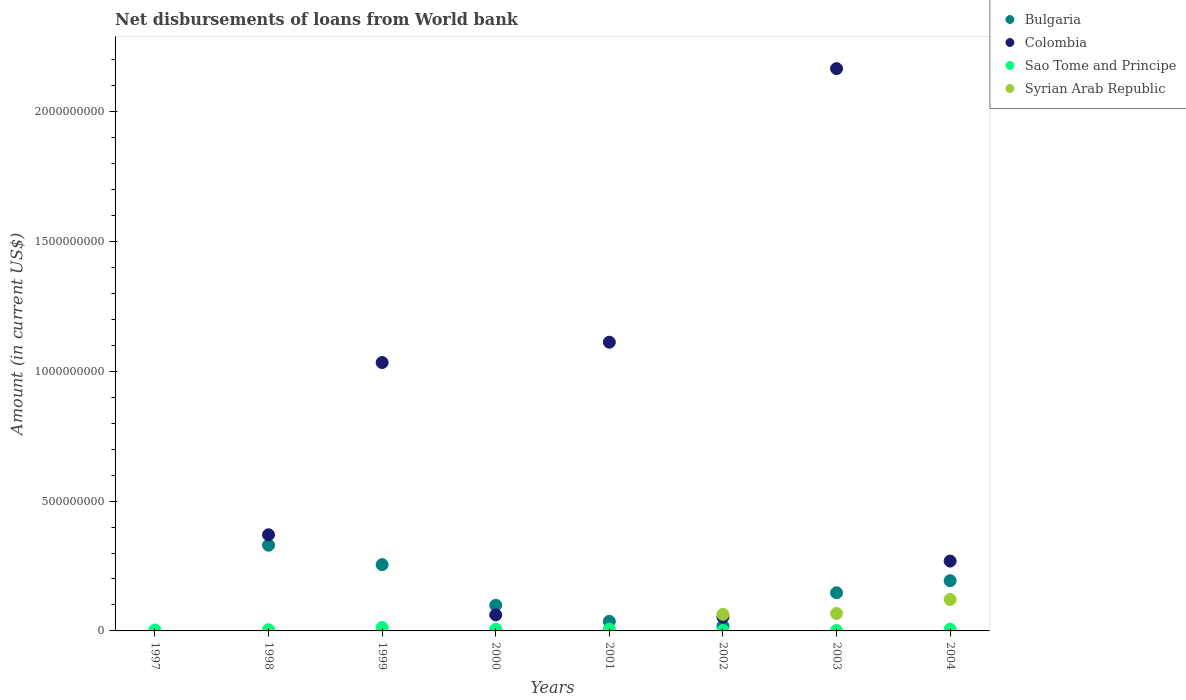Is the number of dotlines equal to the number of legend labels?
Offer a very short reply. No. What is the amount of loan disbursed from World Bank in Sao Tome and Principe in 2003?
Your response must be concise. 1.70e+06. Across all years, what is the maximum amount of loan disbursed from World Bank in Syrian Arab Republic?
Your answer should be very brief. 1.21e+08. Across all years, what is the minimum amount of loan disbursed from World Bank in Syrian Arab Republic?
Ensure brevity in your answer.  0. In which year was the amount of loan disbursed from World Bank in Bulgaria maximum?
Your response must be concise. 1998. What is the total amount of loan disbursed from World Bank in Syrian Arab Republic in the graph?
Ensure brevity in your answer.  2.52e+08. What is the difference between the amount of loan disbursed from World Bank in Sao Tome and Principe in 1998 and that in 2004?
Your answer should be compact. -2.05e+06. What is the difference between the amount of loan disbursed from World Bank in Syrian Arab Republic in 2000 and the amount of loan disbursed from World Bank in Colombia in 2001?
Offer a terse response. -1.11e+09. What is the average amount of loan disbursed from World Bank in Colombia per year?
Offer a terse response. 6.33e+08. In the year 2004, what is the difference between the amount of loan disbursed from World Bank in Sao Tome and Principe and amount of loan disbursed from World Bank in Syrian Arab Republic?
Provide a succinct answer. -1.14e+08. In how many years, is the amount of loan disbursed from World Bank in Colombia greater than 1600000000 US$?
Your response must be concise. 1. What is the ratio of the amount of loan disbursed from World Bank in Sao Tome and Principe in 1999 to that in 2002?
Keep it short and to the point. 8.31. What is the difference between the highest and the second highest amount of loan disbursed from World Bank in Bulgaria?
Offer a very short reply. 7.48e+07. What is the difference between the highest and the lowest amount of loan disbursed from World Bank in Bulgaria?
Provide a succinct answer. 3.30e+08. Is the sum of the amount of loan disbursed from World Bank in Colombia in 1998 and 2004 greater than the maximum amount of loan disbursed from World Bank in Sao Tome and Principe across all years?
Offer a terse response. Yes. Is it the case that in every year, the sum of the amount of loan disbursed from World Bank in Syrian Arab Republic and amount of loan disbursed from World Bank in Bulgaria  is greater than the sum of amount of loan disbursed from World Bank in Colombia and amount of loan disbursed from World Bank in Sao Tome and Principe?
Your response must be concise. No. Does the amount of loan disbursed from World Bank in Sao Tome and Principe monotonically increase over the years?
Make the answer very short. No. Is the amount of loan disbursed from World Bank in Syrian Arab Republic strictly less than the amount of loan disbursed from World Bank in Bulgaria over the years?
Provide a short and direct response. No. What is the difference between two consecutive major ticks on the Y-axis?
Your response must be concise. 5.00e+08. Are the values on the major ticks of Y-axis written in scientific E-notation?
Make the answer very short. No. Does the graph contain any zero values?
Keep it short and to the point. Yes. Does the graph contain grids?
Give a very brief answer. No. Where does the legend appear in the graph?
Provide a short and direct response. Top right. How are the legend labels stacked?
Ensure brevity in your answer.  Vertical. What is the title of the graph?
Your answer should be compact. Net disbursements of loans from World bank. Does "United States" appear as one of the legend labels in the graph?
Provide a short and direct response. No. What is the label or title of the Y-axis?
Make the answer very short. Amount (in current US$). What is the Amount (in current US$) of Colombia in 1997?
Ensure brevity in your answer.  0. What is the Amount (in current US$) of Sao Tome and Principe in 1997?
Your answer should be very brief. 3.67e+06. What is the Amount (in current US$) of Bulgaria in 1998?
Make the answer very short. 3.30e+08. What is the Amount (in current US$) of Colombia in 1998?
Your response must be concise. 3.70e+08. What is the Amount (in current US$) of Sao Tome and Principe in 1998?
Give a very brief answer. 4.68e+06. What is the Amount (in current US$) of Syrian Arab Republic in 1998?
Provide a succinct answer. 0. What is the Amount (in current US$) of Bulgaria in 1999?
Provide a succinct answer. 2.55e+08. What is the Amount (in current US$) of Colombia in 1999?
Your response must be concise. 1.03e+09. What is the Amount (in current US$) of Sao Tome and Principe in 1999?
Your answer should be compact. 1.31e+07. What is the Amount (in current US$) of Bulgaria in 2000?
Offer a terse response. 9.87e+07. What is the Amount (in current US$) of Colombia in 2000?
Keep it short and to the point. 6.18e+07. What is the Amount (in current US$) of Sao Tome and Principe in 2000?
Give a very brief answer. 6.55e+06. What is the Amount (in current US$) of Bulgaria in 2001?
Provide a succinct answer. 3.70e+07. What is the Amount (in current US$) in Colombia in 2001?
Your response must be concise. 1.11e+09. What is the Amount (in current US$) of Sao Tome and Principe in 2001?
Offer a very short reply. 6.56e+06. What is the Amount (in current US$) of Syrian Arab Republic in 2001?
Offer a very short reply. 0. What is the Amount (in current US$) of Bulgaria in 2002?
Your answer should be compact. 1.90e+07. What is the Amount (in current US$) of Colombia in 2002?
Keep it short and to the point. 5.33e+07. What is the Amount (in current US$) in Sao Tome and Principe in 2002?
Provide a short and direct response. 1.58e+06. What is the Amount (in current US$) of Syrian Arab Republic in 2002?
Your answer should be very brief. 6.37e+07. What is the Amount (in current US$) of Bulgaria in 2003?
Ensure brevity in your answer.  1.47e+08. What is the Amount (in current US$) of Colombia in 2003?
Offer a very short reply. 2.17e+09. What is the Amount (in current US$) of Sao Tome and Principe in 2003?
Provide a succinct answer. 1.70e+06. What is the Amount (in current US$) in Syrian Arab Republic in 2003?
Offer a very short reply. 6.73e+07. What is the Amount (in current US$) in Bulgaria in 2004?
Keep it short and to the point. 1.93e+08. What is the Amount (in current US$) of Colombia in 2004?
Your answer should be compact. 2.69e+08. What is the Amount (in current US$) of Sao Tome and Principe in 2004?
Offer a very short reply. 6.74e+06. What is the Amount (in current US$) in Syrian Arab Republic in 2004?
Your response must be concise. 1.21e+08. Across all years, what is the maximum Amount (in current US$) in Bulgaria?
Give a very brief answer. 3.30e+08. Across all years, what is the maximum Amount (in current US$) in Colombia?
Your answer should be compact. 2.17e+09. Across all years, what is the maximum Amount (in current US$) in Sao Tome and Principe?
Offer a terse response. 1.31e+07. Across all years, what is the maximum Amount (in current US$) of Syrian Arab Republic?
Give a very brief answer. 1.21e+08. Across all years, what is the minimum Amount (in current US$) of Colombia?
Keep it short and to the point. 0. Across all years, what is the minimum Amount (in current US$) of Sao Tome and Principe?
Provide a succinct answer. 1.58e+06. Across all years, what is the minimum Amount (in current US$) in Syrian Arab Republic?
Provide a short and direct response. 0. What is the total Amount (in current US$) in Bulgaria in the graph?
Your answer should be very brief. 1.08e+09. What is the total Amount (in current US$) of Colombia in the graph?
Keep it short and to the point. 5.07e+09. What is the total Amount (in current US$) of Sao Tome and Principe in the graph?
Provide a short and direct response. 4.46e+07. What is the total Amount (in current US$) in Syrian Arab Republic in the graph?
Offer a terse response. 2.52e+08. What is the difference between the Amount (in current US$) in Sao Tome and Principe in 1997 and that in 1998?
Offer a terse response. -1.02e+06. What is the difference between the Amount (in current US$) of Sao Tome and Principe in 1997 and that in 1999?
Provide a short and direct response. -9.46e+06. What is the difference between the Amount (in current US$) in Sao Tome and Principe in 1997 and that in 2000?
Give a very brief answer. -2.88e+06. What is the difference between the Amount (in current US$) in Sao Tome and Principe in 1997 and that in 2001?
Make the answer very short. -2.89e+06. What is the difference between the Amount (in current US$) of Sao Tome and Principe in 1997 and that in 2002?
Offer a terse response. 2.08e+06. What is the difference between the Amount (in current US$) of Sao Tome and Principe in 1997 and that in 2003?
Your answer should be compact. 1.97e+06. What is the difference between the Amount (in current US$) of Sao Tome and Principe in 1997 and that in 2004?
Your answer should be very brief. -3.07e+06. What is the difference between the Amount (in current US$) in Bulgaria in 1998 and that in 1999?
Provide a succinct answer. 7.48e+07. What is the difference between the Amount (in current US$) of Colombia in 1998 and that in 1999?
Provide a short and direct response. -6.63e+08. What is the difference between the Amount (in current US$) in Sao Tome and Principe in 1998 and that in 1999?
Provide a succinct answer. -8.45e+06. What is the difference between the Amount (in current US$) in Bulgaria in 1998 and that in 2000?
Offer a very short reply. 2.31e+08. What is the difference between the Amount (in current US$) in Colombia in 1998 and that in 2000?
Provide a short and direct response. 3.09e+08. What is the difference between the Amount (in current US$) in Sao Tome and Principe in 1998 and that in 2000?
Your answer should be compact. -1.86e+06. What is the difference between the Amount (in current US$) of Bulgaria in 1998 and that in 2001?
Your response must be concise. 2.93e+08. What is the difference between the Amount (in current US$) in Colombia in 1998 and that in 2001?
Give a very brief answer. -7.42e+08. What is the difference between the Amount (in current US$) in Sao Tome and Principe in 1998 and that in 2001?
Offer a terse response. -1.87e+06. What is the difference between the Amount (in current US$) in Bulgaria in 1998 and that in 2002?
Your response must be concise. 3.11e+08. What is the difference between the Amount (in current US$) of Colombia in 1998 and that in 2002?
Keep it short and to the point. 3.17e+08. What is the difference between the Amount (in current US$) in Sao Tome and Principe in 1998 and that in 2002?
Give a very brief answer. 3.10e+06. What is the difference between the Amount (in current US$) in Bulgaria in 1998 and that in 2003?
Give a very brief answer. 1.83e+08. What is the difference between the Amount (in current US$) of Colombia in 1998 and that in 2003?
Provide a short and direct response. -1.80e+09. What is the difference between the Amount (in current US$) in Sao Tome and Principe in 1998 and that in 2003?
Your answer should be compact. 2.98e+06. What is the difference between the Amount (in current US$) of Bulgaria in 1998 and that in 2004?
Give a very brief answer. 1.37e+08. What is the difference between the Amount (in current US$) of Colombia in 1998 and that in 2004?
Offer a terse response. 1.01e+08. What is the difference between the Amount (in current US$) of Sao Tome and Principe in 1998 and that in 2004?
Give a very brief answer. -2.05e+06. What is the difference between the Amount (in current US$) of Bulgaria in 1999 and that in 2000?
Give a very brief answer. 1.57e+08. What is the difference between the Amount (in current US$) in Colombia in 1999 and that in 2000?
Provide a succinct answer. 9.72e+08. What is the difference between the Amount (in current US$) of Sao Tome and Principe in 1999 and that in 2000?
Give a very brief answer. 6.58e+06. What is the difference between the Amount (in current US$) of Bulgaria in 1999 and that in 2001?
Offer a terse response. 2.18e+08. What is the difference between the Amount (in current US$) in Colombia in 1999 and that in 2001?
Ensure brevity in your answer.  -7.83e+07. What is the difference between the Amount (in current US$) in Sao Tome and Principe in 1999 and that in 2001?
Offer a terse response. 6.57e+06. What is the difference between the Amount (in current US$) in Bulgaria in 1999 and that in 2002?
Your answer should be very brief. 2.36e+08. What is the difference between the Amount (in current US$) in Colombia in 1999 and that in 2002?
Give a very brief answer. 9.80e+08. What is the difference between the Amount (in current US$) of Sao Tome and Principe in 1999 and that in 2002?
Make the answer very short. 1.16e+07. What is the difference between the Amount (in current US$) in Bulgaria in 1999 and that in 2003?
Provide a succinct answer. 1.08e+08. What is the difference between the Amount (in current US$) in Colombia in 1999 and that in 2003?
Keep it short and to the point. -1.13e+09. What is the difference between the Amount (in current US$) in Sao Tome and Principe in 1999 and that in 2003?
Your answer should be very brief. 1.14e+07. What is the difference between the Amount (in current US$) in Bulgaria in 1999 and that in 2004?
Offer a very short reply. 6.19e+07. What is the difference between the Amount (in current US$) in Colombia in 1999 and that in 2004?
Offer a very short reply. 7.65e+08. What is the difference between the Amount (in current US$) in Sao Tome and Principe in 1999 and that in 2004?
Keep it short and to the point. 6.39e+06. What is the difference between the Amount (in current US$) in Bulgaria in 2000 and that in 2001?
Your answer should be compact. 6.17e+07. What is the difference between the Amount (in current US$) in Colombia in 2000 and that in 2001?
Offer a terse response. -1.05e+09. What is the difference between the Amount (in current US$) in Sao Tome and Principe in 2000 and that in 2001?
Your answer should be compact. -8000. What is the difference between the Amount (in current US$) of Bulgaria in 2000 and that in 2002?
Ensure brevity in your answer.  7.97e+07. What is the difference between the Amount (in current US$) in Colombia in 2000 and that in 2002?
Offer a very short reply. 8.49e+06. What is the difference between the Amount (in current US$) of Sao Tome and Principe in 2000 and that in 2002?
Your answer should be compact. 4.97e+06. What is the difference between the Amount (in current US$) in Bulgaria in 2000 and that in 2003?
Provide a short and direct response. -4.83e+07. What is the difference between the Amount (in current US$) of Colombia in 2000 and that in 2003?
Offer a very short reply. -2.10e+09. What is the difference between the Amount (in current US$) of Sao Tome and Principe in 2000 and that in 2003?
Make the answer very short. 4.85e+06. What is the difference between the Amount (in current US$) in Bulgaria in 2000 and that in 2004?
Offer a terse response. -9.47e+07. What is the difference between the Amount (in current US$) of Colombia in 2000 and that in 2004?
Your answer should be compact. -2.07e+08. What is the difference between the Amount (in current US$) of Sao Tome and Principe in 2000 and that in 2004?
Offer a very short reply. -1.87e+05. What is the difference between the Amount (in current US$) in Bulgaria in 2001 and that in 2002?
Give a very brief answer. 1.80e+07. What is the difference between the Amount (in current US$) in Colombia in 2001 and that in 2002?
Your answer should be compact. 1.06e+09. What is the difference between the Amount (in current US$) in Sao Tome and Principe in 2001 and that in 2002?
Give a very brief answer. 4.98e+06. What is the difference between the Amount (in current US$) of Bulgaria in 2001 and that in 2003?
Provide a short and direct response. -1.10e+08. What is the difference between the Amount (in current US$) of Colombia in 2001 and that in 2003?
Offer a very short reply. -1.05e+09. What is the difference between the Amount (in current US$) of Sao Tome and Principe in 2001 and that in 2003?
Make the answer very short. 4.86e+06. What is the difference between the Amount (in current US$) in Bulgaria in 2001 and that in 2004?
Your answer should be compact. -1.56e+08. What is the difference between the Amount (in current US$) of Colombia in 2001 and that in 2004?
Keep it short and to the point. 8.43e+08. What is the difference between the Amount (in current US$) in Sao Tome and Principe in 2001 and that in 2004?
Make the answer very short. -1.79e+05. What is the difference between the Amount (in current US$) in Bulgaria in 2002 and that in 2003?
Ensure brevity in your answer.  -1.28e+08. What is the difference between the Amount (in current US$) of Colombia in 2002 and that in 2003?
Ensure brevity in your answer.  -2.11e+09. What is the difference between the Amount (in current US$) of Sao Tome and Principe in 2002 and that in 2003?
Your answer should be compact. -1.19e+05. What is the difference between the Amount (in current US$) of Syrian Arab Republic in 2002 and that in 2003?
Give a very brief answer. -3.60e+06. What is the difference between the Amount (in current US$) of Bulgaria in 2002 and that in 2004?
Provide a short and direct response. -1.74e+08. What is the difference between the Amount (in current US$) in Colombia in 2002 and that in 2004?
Your response must be concise. -2.16e+08. What is the difference between the Amount (in current US$) of Sao Tome and Principe in 2002 and that in 2004?
Make the answer very short. -5.16e+06. What is the difference between the Amount (in current US$) of Syrian Arab Republic in 2002 and that in 2004?
Make the answer very short. -5.73e+07. What is the difference between the Amount (in current US$) of Bulgaria in 2003 and that in 2004?
Your answer should be very brief. -4.64e+07. What is the difference between the Amount (in current US$) of Colombia in 2003 and that in 2004?
Provide a short and direct response. 1.90e+09. What is the difference between the Amount (in current US$) in Sao Tome and Principe in 2003 and that in 2004?
Make the answer very short. -5.04e+06. What is the difference between the Amount (in current US$) of Syrian Arab Republic in 2003 and that in 2004?
Ensure brevity in your answer.  -5.37e+07. What is the difference between the Amount (in current US$) in Sao Tome and Principe in 1997 and the Amount (in current US$) in Syrian Arab Republic in 2002?
Provide a succinct answer. -6.01e+07. What is the difference between the Amount (in current US$) of Sao Tome and Principe in 1997 and the Amount (in current US$) of Syrian Arab Republic in 2003?
Give a very brief answer. -6.37e+07. What is the difference between the Amount (in current US$) of Sao Tome and Principe in 1997 and the Amount (in current US$) of Syrian Arab Republic in 2004?
Your answer should be very brief. -1.17e+08. What is the difference between the Amount (in current US$) of Bulgaria in 1998 and the Amount (in current US$) of Colombia in 1999?
Keep it short and to the point. -7.03e+08. What is the difference between the Amount (in current US$) in Bulgaria in 1998 and the Amount (in current US$) in Sao Tome and Principe in 1999?
Provide a succinct answer. 3.17e+08. What is the difference between the Amount (in current US$) of Colombia in 1998 and the Amount (in current US$) of Sao Tome and Principe in 1999?
Make the answer very short. 3.57e+08. What is the difference between the Amount (in current US$) of Bulgaria in 1998 and the Amount (in current US$) of Colombia in 2000?
Ensure brevity in your answer.  2.68e+08. What is the difference between the Amount (in current US$) of Bulgaria in 1998 and the Amount (in current US$) of Sao Tome and Principe in 2000?
Keep it short and to the point. 3.24e+08. What is the difference between the Amount (in current US$) of Colombia in 1998 and the Amount (in current US$) of Sao Tome and Principe in 2000?
Your response must be concise. 3.64e+08. What is the difference between the Amount (in current US$) in Bulgaria in 1998 and the Amount (in current US$) in Colombia in 2001?
Your answer should be compact. -7.82e+08. What is the difference between the Amount (in current US$) in Bulgaria in 1998 and the Amount (in current US$) in Sao Tome and Principe in 2001?
Give a very brief answer. 3.24e+08. What is the difference between the Amount (in current US$) in Colombia in 1998 and the Amount (in current US$) in Sao Tome and Principe in 2001?
Your answer should be very brief. 3.64e+08. What is the difference between the Amount (in current US$) of Bulgaria in 1998 and the Amount (in current US$) of Colombia in 2002?
Make the answer very short. 2.77e+08. What is the difference between the Amount (in current US$) of Bulgaria in 1998 and the Amount (in current US$) of Sao Tome and Principe in 2002?
Make the answer very short. 3.29e+08. What is the difference between the Amount (in current US$) of Bulgaria in 1998 and the Amount (in current US$) of Syrian Arab Republic in 2002?
Give a very brief answer. 2.66e+08. What is the difference between the Amount (in current US$) in Colombia in 1998 and the Amount (in current US$) in Sao Tome and Principe in 2002?
Ensure brevity in your answer.  3.69e+08. What is the difference between the Amount (in current US$) in Colombia in 1998 and the Amount (in current US$) in Syrian Arab Republic in 2002?
Provide a short and direct response. 3.07e+08. What is the difference between the Amount (in current US$) of Sao Tome and Principe in 1998 and the Amount (in current US$) of Syrian Arab Republic in 2002?
Your response must be concise. -5.91e+07. What is the difference between the Amount (in current US$) of Bulgaria in 1998 and the Amount (in current US$) of Colombia in 2003?
Your response must be concise. -1.84e+09. What is the difference between the Amount (in current US$) in Bulgaria in 1998 and the Amount (in current US$) in Sao Tome and Principe in 2003?
Keep it short and to the point. 3.28e+08. What is the difference between the Amount (in current US$) of Bulgaria in 1998 and the Amount (in current US$) of Syrian Arab Republic in 2003?
Offer a very short reply. 2.63e+08. What is the difference between the Amount (in current US$) of Colombia in 1998 and the Amount (in current US$) of Sao Tome and Principe in 2003?
Offer a terse response. 3.69e+08. What is the difference between the Amount (in current US$) in Colombia in 1998 and the Amount (in current US$) in Syrian Arab Republic in 2003?
Offer a very short reply. 3.03e+08. What is the difference between the Amount (in current US$) in Sao Tome and Principe in 1998 and the Amount (in current US$) in Syrian Arab Republic in 2003?
Your answer should be compact. -6.27e+07. What is the difference between the Amount (in current US$) of Bulgaria in 1998 and the Amount (in current US$) of Colombia in 2004?
Offer a very short reply. 6.12e+07. What is the difference between the Amount (in current US$) of Bulgaria in 1998 and the Amount (in current US$) of Sao Tome and Principe in 2004?
Keep it short and to the point. 3.23e+08. What is the difference between the Amount (in current US$) of Bulgaria in 1998 and the Amount (in current US$) of Syrian Arab Republic in 2004?
Provide a succinct answer. 2.09e+08. What is the difference between the Amount (in current US$) in Colombia in 1998 and the Amount (in current US$) in Sao Tome and Principe in 2004?
Offer a terse response. 3.64e+08. What is the difference between the Amount (in current US$) in Colombia in 1998 and the Amount (in current US$) in Syrian Arab Republic in 2004?
Provide a succinct answer. 2.49e+08. What is the difference between the Amount (in current US$) of Sao Tome and Principe in 1998 and the Amount (in current US$) of Syrian Arab Republic in 2004?
Offer a terse response. -1.16e+08. What is the difference between the Amount (in current US$) in Bulgaria in 1999 and the Amount (in current US$) in Colombia in 2000?
Offer a terse response. 1.93e+08. What is the difference between the Amount (in current US$) in Bulgaria in 1999 and the Amount (in current US$) in Sao Tome and Principe in 2000?
Provide a short and direct response. 2.49e+08. What is the difference between the Amount (in current US$) of Colombia in 1999 and the Amount (in current US$) of Sao Tome and Principe in 2000?
Provide a succinct answer. 1.03e+09. What is the difference between the Amount (in current US$) in Bulgaria in 1999 and the Amount (in current US$) in Colombia in 2001?
Provide a short and direct response. -8.57e+08. What is the difference between the Amount (in current US$) of Bulgaria in 1999 and the Amount (in current US$) of Sao Tome and Principe in 2001?
Offer a very short reply. 2.49e+08. What is the difference between the Amount (in current US$) in Colombia in 1999 and the Amount (in current US$) in Sao Tome and Principe in 2001?
Make the answer very short. 1.03e+09. What is the difference between the Amount (in current US$) in Bulgaria in 1999 and the Amount (in current US$) in Colombia in 2002?
Your response must be concise. 2.02e+08. What is the difference between the Amount (in current US$) in Bulgaria in 1999 and the Amount (in current US$) in Sao Tome and Principe in 2002?
Your answer should be very brief. 2.54e+08. What is the difference between the Amount (in current US$) in Bulgaria in 1999 and the Amount (in current US$) in Syrian Arab Republic in 2002?
Keep it short and to the point. 1.92e+08. What is the difference between the Amount (in current US$) in Colombia in 1999 and the Amount (in current US$) in Sao Tome and Principe in 2002?
Offer a terse response. 1.03e+09. What is the difference between the Amount (in current US$) in Colombia in 1999 and the Amount (in current US$) in Syrian Arab Republic in 2002?
Provide a short and direct response. 9.70e+08. What is the difference between the Amount (in current US$) in Sao Tome and Principe in 1999 and the Amount (in current US$) in Syrian Arab Republic in 2002?
Your answer should be compact. -5.06e+07. What is the difference between the Amount (in current US$) of Bulgaria in 1999 and the Amount (in current US$) of Colombia in 2003?
Keep it short and to the point. -1.91e+09. What is the difference between the Amount (in current US$) in Bulgaria in 1999 and the Amount (in current US$) in Sao Tome and Principe in 2003?
Offer a very short reply. 2.54e+08. What is the difference between the Amount (in current US$) of Bulgaria in 1999 and the Amount (in current US$) of Syrian Arab Republic in 2003?
Keep it short and to the point. 1.88e+08. What is the difference between the Amount (in current US$) of Colombia in 1999 and the Amount (in current US$) of Sao Tome and Principe in 2003?
Ensure brevity in your answer.  1.03e+09. What is the difference between the Amount (in current US$) of Colombia in 1999 and the Amount (in current US$) of Syrian Arab Republic in 2003?
Your answer should be compact. 9.66e+08. What is the difference between the Amount (in current US$) in Sao Tome and Principe in 1999 and the Amount (in current US$) in Syrian Arab Republic in 2003?
Give a very brief answer. -5.42e+07. What is the difference between the Amount (in current US$) of Bulgaria in 1999 and the Amount (in current US$) of Colombia in 2004?
Offer a very short reply. -1.36e+07. What is the difference between the Amount (in current US$) in Bulgaria in 1999 and the Amount (in current US$) in Sao Tome and Principe in 2004?
Offer a terse response. 2.49e+08. What is the difference between the Amount (in current US$) in Bulgaria in 1999 and the Amount (in current US$) in Syrian Arab Republic in 2004?
Provide a succinct answer. 1.34e+08. What is the difference between the Amount (in current US$) of Colombia in 1999 and the Amount (in current US$) of Sao Tome and Principe in 2004?
Your answer should be very brief. 1.03e+09. What is the difference between the Amount (in current US$) of Colombia in 1999 and the Amount (in current US$) of Syrian Arab Republic in 2004?
Keep it short and to the point. 9.13e+08. What is the difference between the Amount (in current US$) of Sao Tome and Principe in 1999 and the Amount (in current US$) of Syrian Arab Republic in 2004?
Give a very brief answer. -1.08e+08. What is the difference between the Amount (in current US$) of Bulgaria in 2000 and the Amount (in current US$) of Colombia in 2001?
Make the answer very short. -1.01e+09. What is the difference between the Amount (in current US$) of Bulgaria in 2000 and the Amount (in current US$) of Sao Tome and Principe in 2001?
Provide a succinct answer. 9.21e+07. What is the difference between the Amount (in current US$) of Colombia in 2000 and the Amount (in current US$) of Sao Tome and Principe in 2001?
Your response must be concise. 5.52e+07. What is the difference between the Amount (in current US$) of Bulgaria in 2000 and the Amount (in current US$) of Colombia in 2002?
Provide a short and direct response. 4.54e+07. What is the difference between the Amount (in current US$) in Bulgaria in 2000 and the Amount (in current US$) in Sao Tome and Principe in 2002?
Provide a short and direct response. 9.71e+07. What is the difference between the Amount (in current US$) in Bulgaria in 2000 and the Amount (in current US$) in Syrian Arab Republic in 2002?
Keep it short and to the point. 3.49e+07. What is the difference between the Amount (in current US$) in Colombia in 2000 and the Amount (in current US$) in Sao Tome and Principe in 2002?
Ensure brevity in your answer.  6.02e+07. What is the difference between the Amount (in current US$) in Colombia in 2000 and the Amount (in current US$) in Syrian Arab Republic in 2002?
Offer a terse response. -1.94e+06. What is the difference between the Amount (in current US$) in Sao Tome and Principe in 2000 and the Amount (in current US$) in Syrian Arab Republic in 2002?
Offer a very short reply. -5.72e+07. What is the difference between the Amount (in current US$) of Bulgaria in 2000 and the Amount (in current US$) of Colombia in 2003?
Ensure brevity in your answer.  -2.07e+09. What is the difference between the Amount (in current US$) of Bulgaria in 2000 and the Amount (in current US$) of Sao Tome and Principe in 2003?
Provide a short and direct response. 9.70e+07. What is the difference between the Amount (in current US$) in Bulgaria in 2000 and the Amount (in current US$) in Syrian Arab Republic in 2003?
Offer a very short reply. 3.13e+07. What is the difference between the Amount (in current US$) of Colombia in 2000 and the Amount (in current US$) of Sao Tome and Principe in 2003?
Give a very brief answer. 6.01e+07. What is the difference between the Amount (in current US$) in Colombia in 2000 and the Amount (in current US$) in Syrian Arab Republic in 2003?
Keep it short and to the point. -5.54e+06. What is the difference between the Amount (in current US$) of Sao Tome and Principe in 2000 and the Amount (in current US$) of Syrian Arab Republic in 2003?
Offer a very short reply. -6.08e+07. What is the difference between the Amount (in current US$) in Bulgaria in 2000 and the Amount (in current US$) in Colombia in 2004?
Your answer should be compact. -1.70e+08. What is the difference between the Amount (in current US$) of Bulgaria in 2000 and the Amount (in current US$) of Sao Tome and Principe in 2004?
Offer a terse response. 9.19e+07. What is the difference between the Amount (in current US$) in Bulgaria in 2000 and the Amount (in current US$) in Syrian Arab Republic in 2004?
Provide a succinct answer. -2.24e+07. What is the difference between the Amount (in current US$) in Colombia in 2000 and the Amount (in current US$) in Sao Tome and Principe in 2004?
Provide a short and direct response. 5.51e+07. What is the difference between the Amount (in current US$) in Colombia in 2000 and the Amount (in current US$) in Syrian Arab Republic in 2004?
Offer a very short reply. -5.93e+07. What is the difference between the Amount (in current US$) in Sao Tome and Principe in 2000 and the Amount (in current US$) in Syrian Arab Republic in 2004?
Your answer should be compact. -1.15e+08. What is the difference between the Amount (in current US$) of Bulgaria in 2001 and the Amount (in current US$) of Colombia in 2002?
Your response must be concise. -1.63e+07. What is the difference between the Amount (in current US$) in Bulgaria in 2001 and the Amount (in current US$) in Sao Tome and Principe in 2002?
Your answer should be compact. 3.54e+07. What is the difference between the Amount (in current US$) in Bulgaria in 2001 and the Amount (in current US$) in Syrian Arab Republic in 2002?
Offer a terse response. -2.68e+07. What is the difference between the Amount (in current US$) of Colombia in 2001 and the Amount (in current US$) of Sao Tome and Principe in 2002?
Keep it short and to the point. 1.11e+09. What is the difference between the Amount (in current US$) in Colombia in 2001 and the Amount (in current US$) in Syrian Arab Republic in 2002?
Give a very brief answer. 1.05e+09. What is the difference between the Amount (in current US$) of Sao Tome and Principe in 2001 and the Amount (in current US$) of Syrian Arab Republic in 2002?
Your answer should be very brief. -5.72e+07. What is the difference between the Amount (in current US$) of Bulgaria in 2001 and the Amount (in current US$) of Colombia in 2003?
Give a very brief answer. -2.13e+09. What is the difference between the Amount (in current US$) in Bulgaria in 2001 and the Amount (in current US$) in Sao Tome and Principe in 2003?
Provide a succinct answer. 3.53e+07. What is the difference between the Amount (in current US$) in Bulgaria in 2001 and the Amount (in current US$) in Syrian Arab Republic in 2003?
Offer a terse response. -3.04e+07. What is the difference between the Amount (in current US$) in Colombia in 2001 and the Amount (in current US$) in Sao Tome and Principe in 2003?
Provide a short and direct response. 1.11e+09. What is the difference between the Amount (in current US$) of Colombia in 2001 and the Amount (in current US$) of Syrian Arab Republic in 2003?
Provide a short and direct response. 1.04e+09. What is the difference between the Amount (in current US$) in Sao Tome and Principe in 2001 and the Amount (in current US$) in Syrian Arab Republic in 2003?
Ensure brevity in your answer.  -6.08e+07. What is the difference between the Amount (in current US$) in Bulgaria in 2001 and the Amount (in current US$) in Colombia in 2004?
Make the answer very short. -2.32e+08. What is the difference between the Amount (in current US$) in Bulgaria in 2001 and the Amount (in current US$) in Sao Tome and Principe in 2004?
Your response must be concise. 3.02e+07. What is the difference between the Amount (in current US$) in Bulgaria in 2001 and the Amount (in current US$) in Syrian Arab Republic in 2004?
Your answer should be very brief. -8.41e+07. What is the difference between the Amount (in current US$) in Colombia in 2001 and the Amount (in current US$) in Sao Tome and Principe in 2004?
Your answer should be very brief. 1.11e+09. What is the difference between the Amount (in current US$) of Colombia in 2001 and the Amount (in current US$) of Syrian Arab Republic in 2004?
Provide a short and direct response. 9.91e+08. What is the difference between the Amount (in current US$) in Sao Tome and Principe in 2001 and the Amount (in current US$) in Syrian Arab Republic in 2004?
Provide a succinct answer. -1.14e+08. What is the difference between the Amount (in current US$) of Bulgaria in 2002 and the Amount (in current US$) of Colombia in 2003?
Your answer should be very brief. -2.15e+09. What is the difference between the Amount (in current US$) of Bulgaria in 2002 and the Amount (in current US$) of Sao Tome and Principe in 2003?
Make the answer very short. 1.73e+07. What is the difference between the Amount (in current US$) in Bulgaria in 2002 and the Amount (in current US$) in Syrian Arab Republic in 2003?
Keep it short and to the point. -4.83e+07. What is the difference between the Amount (in current US$) of Colombia in 2002 and the Amount (in current US$) of Sao Tome and Principe in 2003?
Offer a very short reply. 5.16e+07. What is the difference between the Amount (in current US$) in Colombia in 2002 and the Amount (in current US$) in Syrian Arab Republic in 2003?
Make the answer very short. -1.40e+07. What is the difference between the Amount (in current US$) of Sao Tome and Principe in 2002 and the Amount (in current US$) of Syrian Arab Republic in 2003?
Keep it short and to the point. -6.58e+07. What is the difference between the Amount (in current US$) in Bulgaria in 2002 and the Amount (in current US$) in Colombia in 2004?
Your answer should be very brief. -2.50e+08. What is the difference between the Amount (in current US$) in Bulgaria in 2002 and the Amount (in current US$) in Sao Tome and Principe in 2004?
Your answer should be very brief. 1.23e+07. What is the difference between the Amount (in current US$) of Bulgaria in 2002 and the Amount (in current US$) of Syrian Arab Republic in 2004?
Provide a succinct answer. -1.02e+08. What is the difference between the Amount (in current US$) in Colombia in 2002 and the Amount (in current US$) in Sao Tome and Principe in 2004?
Provide a short and direct response. 4.66e+07. What is the difference between the Amount (in current US$) of Colombia in 2002 and the Amount (in current US$) of Syrian Arab Republic in 2004?
Provide a short and direct response. -6.77e+07. What is the difference between the Amount (in current US$) of Sao Tome and Principe in 2002 and the Amount (in current US$) of Syrian Arab Republic in 2004?
Provide a succinct answer. -1.19e+08. What is the difference between the Amount (in current US$) in Bulgaria in 2003 and the Amount (in current US$) in Colombia in 2004?
Your answer should be very brief. -1.22e+08. What is the difference between the Amount (in current US$) of Bulgaria in 2003 and the Amount (in current US$) of Sao Tome and Principe in 2004?
Keep it short and to the point. 1.40e+08. What is the difference between the Amount (in current US$) in Bulgaria in 2003 and the Amount (in current US$) in Syrian Arab Republic in 2004?
Offer a very short reply. 2.60e+07. What is the difference between the Amount (in current US$) of Colombia in 2003 and the Amount (in current US$) of Sao Tome and Principe in 2004?
Keep it short and to the point. 2.16e+09. What is the difference between the Amount (in current US$) of Colombia in 2003 and the Amount (in current US$) of Syrian Arab Republic in 2004?
Your response must be concise. 2.04e+09. What is the difference between the Amount (in current US$) of Sao Tome and Principe in 2003 and the Amount (in current US$) of Syrian Arab Republic in 2004?
Your response must be concise. -1.19e+08. What is the average Amount (in current US$) of Bulgaria per year?
Offer a terse response. 1.35e+08. What is the average Amount (in current US$) of Colombia per year?
Ensure brevity in your answer.  6.33e+08. What is the average Amount (in current US$) of Sao Tome and Principe per year?
Your answer should be very brief. 5.58e+06. What is the average Amount (in current US$) of Syrian Arab Republic per year?
Offer a terse response. 3.15e+07. In the year 1998, what is the difference between the Amount (in current US$) in Bulgaria and Amount (in current US$) in Colombia?
Give a very brief answer. -4.02e+07. In the year 1998, what is the difference between the Amount (in current US$) in Bulgaria and Amount (in current US$) in Sao Tome and Principe?
Ensure brevity in your answer.  3.25e+08. In the year 1998, what is the difference between the Amount (in current US$) of Colombia and Amount (in current US$) of Sao Tome and Principe?
Provide a succinct answer. 3.66e+08. In the year 1999, what is the difference between the Amount (in current US$) of Bulgaria and Amount (in current US$) of Colombia?
Offer a very short reply. -7.78e+08. In the year 1999, what is the difference between the Amount (in current US$) of Bulgaria and Amount (in current US$) of Sao Tome and Principe?
Your response must be concise. 2.42e+08. In the year 1999, what is the difference between the Amount (in current US$) of Colombia and Amount (in current US$) of Sao Tome and Principe?
Your answer should be compact. 1.02e+09. In the year 2000, what is the difference between the Amount (in current US$) in Bulgaria and Amount (in current US$) in Colombia?
Make the answer very short. 3.69e+07. In the year 2000, what is the difference between the Amount (in current US$) of Bulgaria and Amount (in current US$) of Sao Tome and Principe?
Offer a very short reply. 9.21e+07. In the year 2000, what is the difference between the Amount (in current US$) of Colombia and Amount (in current US$) of Sao Tome and Principe?
Your answer should be very brief. 5.53e+07. In the year 2001, what is the difference between the Amount (in current US$) of Bulgaria and Amount (in current US$) of Colombia?
Your response must be concise. -1.07e+09. In the year 2001, what is the difference between the Amount (in current US$) of Bulgaria and Amount (in current US$) of Sao Tome and Principe?
Keep it short and to the point. 3.04e+07. In the year 2001, what is the difference between the Amount (in current US$) in Colombia and Amount (in current US$) in Sao Tome and Principe?
Give a very brief answer. 1.11e+09. In the year 2002, what is the difference between the Amount (in current US$) in Bulgaria and Amount (in current US$) in Colombia?
Ensure brevity in your answer.  -3.43e+07. In the year 2002, what is the difference between the Amount (in current US$) in Bulgaria and Amount (in current US$) in Sao Tome and Principe?
Offer a very short reply. 1.74e+07. In the year 2002, what is the difference between the Amount (in current US$) in Bulgaria and Amount (in current US$) in Syrian Arab Republic?
Ensure brevity in your answer.  -4.47e+07. In the year 2002, what is the difference between the Amount (in current US$) in Colombia and Amount (in current US$) in Sao Tome and Principe?
Provide a succinct answer. 5.17e+07. In the year 2002, what is the difference between the Amount (in current US$) of Colombia and Amount (in current US$) of Syrian Arab Republic?
Your answer should be very brief. -1.04e+07. In the year 2002, what is the difference between the Amount (in current US$) of Sao Tome and Principe and Amount (in current US$) of Syrian Arab Republic?
Your answer should be very brief. -6.22e+07. In the year 2003, what is the difference between the Amount (in current US$) in Bulgaria and Amount (in current US$) in Colombia?
Your answer should be compact. -2.02e+09. In the year 2003, what is the difference between the Amount (in current US$) in Bulgaria and Amount (in current US$) in Sao Tome and Principe?
Offer a terse response. 1.45e+08. In the year 2003, what is the difference between the Amount (in current US$) in Bulgaria and Amount (in current US$) in Syrian Arab Republic?
Your answer should be compact. 7.97e+07. In the year 2003, what is the difference between the Amount (in current US$) of Colombia and Amount (in current US$) of Sao Tome and Principe?
Your answer should be very brief. 2.16e+09. In the year 2003, what is the difference between the Amount (in current US$) of Colombia and Amount (in current US$) of Syrian Arab Republic?
Offer a very short reply. 2.10e+09. In the year 2003, what is the difference between the Amount (in current US$) of Sao Tome and Principe and Amount (in current US$) of Syrian Arab Republic?
Give a very brief answer. -6.56e+07. In the year 2004, what is the difference between the Amount (in current US$) of Bulgaria and Amount (in current US$) of Colombia?
Ensure brevity in your answer.  -7.55e+07. In the year 2004, what is the difference between the Amount (in current US$) in Bulgaria and Amount (in current US$) in Sao Tome and Principe?
Give a very brief answer. 1.87e+08. In the year 2004, what is the difference between the Amount (in current US$) of Bulgaria and Amount (in current US$) of Syrian Arab Republic?
Your answer should be compact. 7.23e+07. In the year 2004, what is the difference between the Amount (in current US$) of Colombia and Amount (in current US$) of Sao Tome and Principe?
Provide a succinct answer. 2.62e+08. In the year 2004, what is the difference between the Amount (in current US$) in Colombia and Amount (in current US$) in Syrian Arab Republic?
Make the answer very short. 1.48e+08. In the year 2004, what is the difference between the Amount (in current US$) of Sao Tome and Principe and Amount (in current US$) of Syrian Arab Republic?
Offer a terse response. -1.14e+08. What is the ratio of the Amount (in current US$) in Sao Tome and Principe in 1997 to that in 1998?
Make the answer very short. 0.78. What is the ratio of the Amount (in current US$) in Sao Tome and Principe in 1997 to that in 1999?
Keep it short and to the point. 0.28. What is the ratio of the Amount (in current US$) of Sao Tome and Principe in 1997 to that in 2000?
Your answer should be very brief. 0.56. What is the ratio of the Amount (in current US$) in Sao Tome and Principe in 1997 to that in 2001?
Your answer should be compact. 0.56. What is the ratio of the Amount (in current US$) in Sao Tome and Principe in 1997 to that in 2002?
Your answer should be compact. 2.32. What is the ratio of the Amount (in current US$) in Sao Tome and Principe in 1997 to that in 2003?
Offer a terse response. 2.16. What is the ratio of the Amount (in current US$) in Sao Tome and Principe in 1997 to that in 2004?
Your answer should be very brief. 0.54. What is the ratio of the Amount (in current US$) of Bulgaria in 1998 to that in 1999?
Provide a succinct answer. 1.29. What is the ratio of the Amount (in current US$) in Colombia in 1998 to that in 1999?
Your response must be concise. 0.36. What is the ratio of the Amount (in current US$) of Sao Tome and Principe in 1998 to that in 1999?
Your response must be concise. 0.36. What is the ratio of the Amount (in current US$) in Bulgaria in 1998 to that in 2000?
Provide a short and direct response. 3.35. What is the ratio of the Amount (in current US$) of Colombia in 1998 to that in 2000?
Offer a terse response. 5.99. What is the ratio of the Amount (in current US$) of Sao Tome and Principe in 1998 to that in 2000?
Keep it short and to the point. 0.72. What is the ratio of the Amount (in current US$) of Bulgaria in 1998 to that in 2001?
Ensure brevity in your answer.  8.93. What is the ratio of the Amount (in current US$) of Colombia in 1998 to that in 2001?
Provide a succinct answer. 0.33. What is the ratio of the Amount (in current US$) in Sao Tome and Principe in 1998 to that in 2001?
Provide a short and direct response. 0.71. What is the ratio of the Amount (in current US$) in Bulgaria in 1998 to that in 2002?
Your answer should be very brief. 17.36. What is the ratio of the Amount (in current US$) of Colombia in 1998 to that in 2002?
Your answer should be very brief. 6.95. What is the ratio of the Amount (in current US$) in Sao Tome and Principe in 1998 to that in 2002?
Offer a very short reply. 2.96. What is the ratio of the Amount (in current US$) of Bulgaria in 1998 to that in 2003?
Give a very brief answer. 2.25. What is the ratio of the Amount (in current US$) of Colombia in 1998 to that in 2003?
Ensure brevity in your answer.  0.17. What is the ratio of the Amount (in current US$) in Sao Tome and Principe in 1998 to that in 2003?
Provide a short and direct response. 2.76. What is the ratio of the Amount (in current US$) in Bulgaria in 1998 to that in 2004?
Provide a succinct answer. 1.71. What is the ratio of the Amount (in current US$) in Colombia in 1998 to that in 2004?
Keep it short and to the point. 1.38. What is the ratio of the Amount (in current US$) in Sao Tome and Principe in 1998 to that in 2004?
Ensure brevity in your answer.  0.7. What is the ratio of the Amount (in current US$) in Bulgaria in 1999 to that in 2000?
Provide a short and direct response. 2.59. What is the ratio of the Amount (in current US$) in Colombia in 1999 to that in 2000?
Provide a succinct answer. 16.72. What is the ratio of the Amount (in current US$) in Sao Tome and Principe in 1999 to that in 2000?
Give a very brief answer. 2. What is the ratio of the Amount (in current US$) of Bulgaria in 1999 to that in 2001?
Provide a short and direct response. 6.91. What is the ratio of the Amount (in current US$) in Colombia in 1999 to that in 2001?
Provide a succinct answer. 0.93. What is the ratio of the Amount (in current US$) of Sao Tome and Principe in 1999 to that in 2001?
Keep it short and to the point. 2. What is the ratio of the Amount (in current US$) of Bulgaria in 1999 to that in 2002?
Your response must be concise. 13.43. What is the ratio of the Amount (in current US$) in Colombia in 1999 to that in 2002?
Provide a short and direct response. 19.39. What is the ratio of the Amount (in current US$) in Sao Tome and Principe in 1999 to that in 2002?
Keep it short and to the point. 8.31. What is the ratio of the Amount (in current US$) of Bulgaria in 1999 to that in 2003?
Your answer should be compact. 1.74. What is the ratio of the Amount (in current US$) in Colombia in 1999 to that in 2003?
Your answer should be compact. 0.48. What is the ratio of the Amount (in current US$) of Sao Tome and Principe in 1999 to that in 2003?
Ensure brevity in your answer.  7.72. What is the ratio of the Amount (in current US$) of Bulgaria in 1999 to that in 2004?
Your answer should be compact. 1.32. What is the ratio of the Amount (in current US$) in Colombia in 1999 to that in 2004?
Your answer should be very brief. 3.84. What is the ratio of the Amount (in current US$) in Sao Tome and Principe in 1999 to that in 2004?
Offer a very short reply. 1.95. What is the ratio of the Amount (in current US$) of Bulgaria in 2000 to that in 2001?
Provide a succinct answer. 2.67. What is the ratio of the Amount (in current US$) of Colombia in 2000 to that in 2001?
Make the answer very short. 0.06. What is the ratio of the Amount (in current US$) of Bulgaria in 2000 to that in 2002?
Provide a succinct answer. 5.19. What is the ratio of the Amount (in current US$) of Colombia in 2000 to that in 2002?
Your response must be concise. 1.16. What is the ratio of the Amount (in current US$) of Sao Tome and Principe in 2000 to that in 2002?
Give a very brief answer. 4.14. What is the ratio of the Amount (in current US$) in Bulgaria in 2000 to that in 2003?
Ensure brevity in your answer.  0.67. What is the ratio of the Amount (in current US$) in Colombia in 2000 to that in 2003?
Make the answer very short. 0.03. What is the ratio of the Amount (in current US$) of Sao Tome and Principe in 2000 to that in 2003?
Give a very brief answer. 3.85. What is the ratio of the Amount (in current US$) of Bulgaria in 2000 to that in 2004?
Make the answer very short. 0.51. What is the ratio of the Amount (in current US$) in Colombia in 2000 to that in 2004?
Keep it short and to the point. 0.23. What is the ratio of the Amount (in current US$) of Sao Tome and Principe in 2000 to that in 2004?
Give a very brief answer. 0.97. What is the ratio of the Amount (in current US$) in Bulgaria in 2001 to that in 2002?
Provide a short and direct response. 1.94. What is the ratio of the Amount (in current US$) in Colombia in 2001 to that in 2002?
Offer a terse response. 20.85. What is the ratio of the Amount (in current US$) of Sao Tome and Principe in 2001 to that in 2002?
Keep it short and to the point. 4.15. What is the ratio of the Amount (in current US$) of Bulgaria in 2001 to that in 2003?
Give a very brief answer. 0.25. What is the ratio of the Amount (in current US$) in Colombia in 2001 to that in 2003?
Offer a terse response. 0.51. What is the ratio of the Amount (in current US$) in Sao Tome and Principe in 2001 to that in 2003?
Offer a very short reply. 3.86. What is the ratio of the Amount (in current US$) of Bulgaria in 2001 to that in 2004?
Your answer should be very brief. 0.19. What is the ratio of the Amount (in current US$) of Colombia in 2001 to that in 2004?
Your answer should be compact. 4.13. What is the ratio of the Amount (in current US$) of Sao Tome and Principe in 2001 to that in 2004?
Your response must be concise. 0.97. What is the ratio of the Amount (in current US$) of Bulgaria in 2002 to that in 2003?
Ensure brevity in your answer.  0.13. What is the ratio of the Amount (in current US$) of Colombia in 2002 to that in 2003?
Offer a terse response. 0.02. What is the ratio of the Amount (in current US$) in Sao Tome and Principe in 2002 to that in 2003?
Offer a terse response. 0.93. What is the ratio of the Amount (in current US$) in Syrian Arab Republic in 2002 to that in 2003?
Provide a succinct answer. 0.95. What is the ratio of the Amount (in current US$) in Bulgaria in 2002 to that in 2004?
Make the answer very short. 0.1. What is the ratio of the Amount (in current US$) in Colombia in 2002 to that in 2004?
Make the answer very short. 0.2. What is the ratio of the Amount (in current US$) in Sao Tome and Principe in 2002 to that in 2004?
Ensure brevity in your answer.  0.23. What is the ratio of the Amount (in current US$) of Syrian Arab Republic in 2002 to that in 2004?
Your answer should be compact. 0.53. What is the ratio of the Amount (in current US$) of Bulgaria in 2003 to that in 2004?
Your answer should be compact. 0.76. What is the ratio of the Amount (in current US$) in Colombia in 2003 to that in 2004?
Provide a succinct answer. 8.05. What is the ratio of the Amount (in current US$) in Sao Tome and Principe in 2003 to that in 2004?
Offer a terse response. 0.25. What is the ratio of the Amount (in current US$) of Syrian Arab Republic in 2003 to that in 2004?
Your response must be concise. 0.56. What is the difference between the highest and the second highest Amount (in current US$) in Bulgaria?
Your response must be concise. 7.48e+07. What is the difference between the highest and the second highest Amount (in current US$) in Colombia?
Offer a terse response. 1.05e+09. What is the difference between the highest and the second highest Amount (in current US$) in Sao Tome and Principe?
Give a very brief answer. 6.39e+06. What is the difference between the highest and the second highest Amount (in current US$) of Syrian Arab Republic?
Provide a short and direct response. 5.37e+07. What is the difference between the highest and the lowest Amount (in current US$) of Bulgaria?
Your answer should be compact. 3.30e+08. What is the difference between the highest and the lowest Amount (in current US$) of Colombia?
Offer a very short reply. 2.17e+09. What is the difference between the highest and the lowest Amount (in current US$) of Sao Tome and Principe?
Your response must be concise. 1.16e+07. What is the difference between the highest and the lowest Amount (in current US$) of Syrian Arab Republic?
Provide a succinct answer. 1.21e+08. 